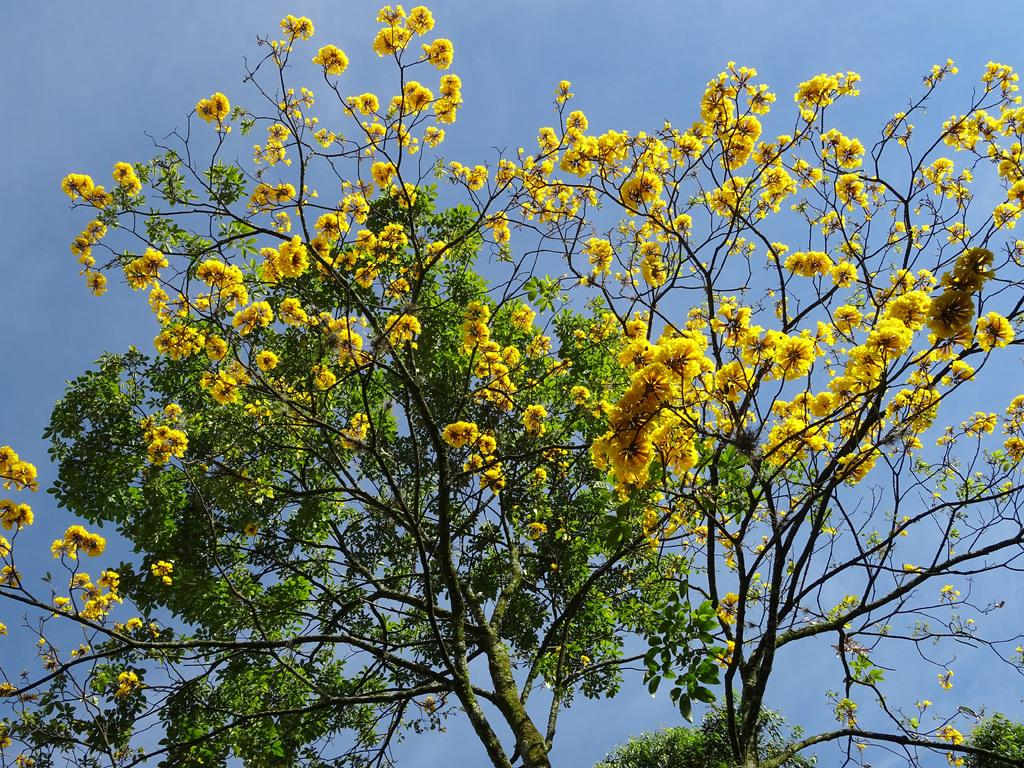What type of tree is present in the image? There is a tree with yellow flowers in the image. Can you describe the positioning of the trees in the image? There is another tree behind the first tree. What can be seen in the background of the image? The sky is visible in the background of the image. What type of bread can be seen hanging from the tree in the image? There is no bread present in the image; it features a tree with yellow flowers and another tree behind it. 